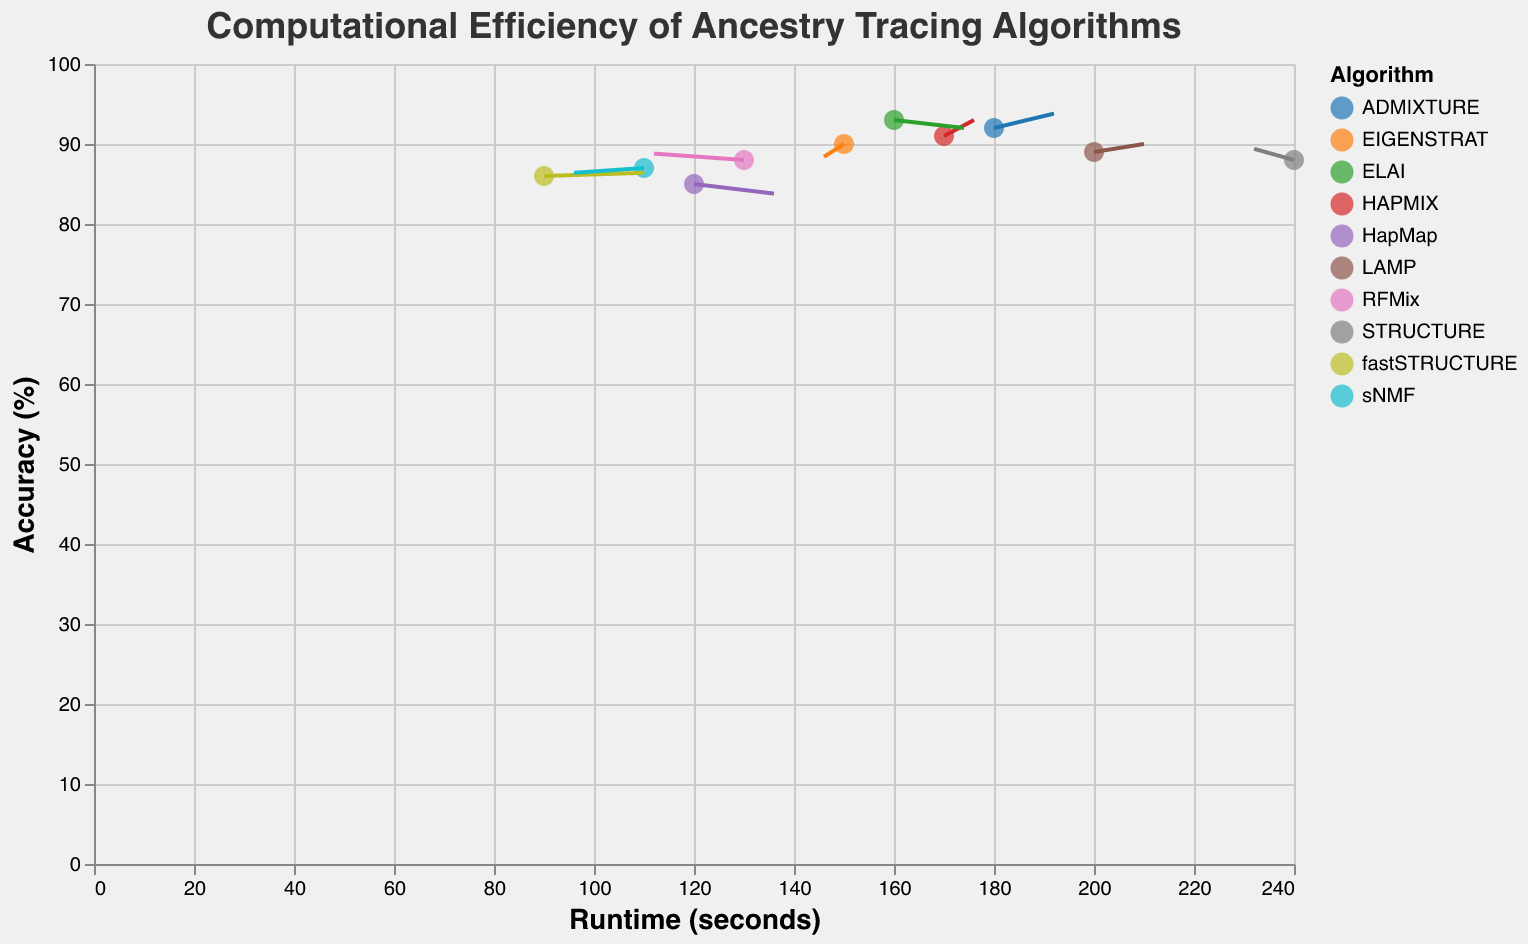What is the title of the figure? The figure's title is located at the top and provides a brief description of the figure's content, which is "Computational Efficiency of Ancestry Tracing Algorithms"
Answer: Computational Efficiency of Ancestry Tracing Algorithms Which algorithm has the highest runtime? To determine the algorithm with the highest runtime, look for the highest X-axis value, which is 240 seconds, associated with the STRUCTURE algorithm
Answer: STRUCTURE What is the accuracy of the EIGENSTRAT algorithm? Identify the EIGENSTRAT algorithm's data point and read the Y-axis value, which shows its accuracy percentage, indicated as 90%
Answer: 90% Which algorithm shows the largest positive change in accuracy based on their vectors? Find the algorithm with the highest upward vector or Y_Vector, which is HAPMIX with a Y_Vector of 1.0. The change can be calculated as the vector value (1.0) multiplied by the scaling factor (2), resulting in a significant positive change of 2%
Answer: HAPMIX What is the runtime and accuracy of the algorithm that shows the highest downward vector in accuracy? The EIGENSTRAT algorithm has the largest negative Y_Vector of -0.8, indicating a downward change. The runtime (X-axis value) is 150 seconds, and the accuracy (Y-axis value) is 90%
Answer: Runtime: 150 seconds, Accuracy: 90% How many algorithms have accuracy percentages greater than 90%? Count the data points with the Y-axis value greater than 90%. The algorithms ADMIXTURE (92%), HAPMIX (91%), and ELAI (93%) fit this criterion, totaling three algorithms
Answer: 3 Which algorithm shows a negative X_Vector but a positive Y_Vector? Look for data points with a negative X_Vector and positive Y_Vector. The STRUCTURE algorithm has X_Vector: -0.4 and Y_Vector: 0.7
Answer: STRUCTURE What is the runtime of the fastest ancestry tracing algorithm? The fastest runtime corresponds to the lowest X-axis value. The fastSTRUCTURE algorithm has the lowest runtime of 90 seconds
Answer: 90 seconds Between RFMix and sNMF, which algorithm has a higher accuracy? Compare the Y-axis values for RFMix and sNMF, which are 88% and 87%, respectively. RFMix has the higher accuracy
Answer: RFMix Which algorithm has the largest leftward vector (negative X_Vector)? Identify the algorithm with the most negative X_Vector value. RFMix has the largest leftward vector with an X_Vector of -0.9
Answer: RFMix 